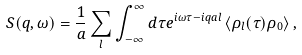Convert formula to latex. <formula><loc_0><loc_0><loc_500><loc_500>S ( q , \omega ) = \frac { 1 } { a } \sum _ { l } \int _ { - \infty } ^ { \infty } d \tau e ^ { i \omega \tau - i q a l } \left \langle \rho _ { l } ( \tau ) \rho _ { 0 } \right \rangle ,</formula> 